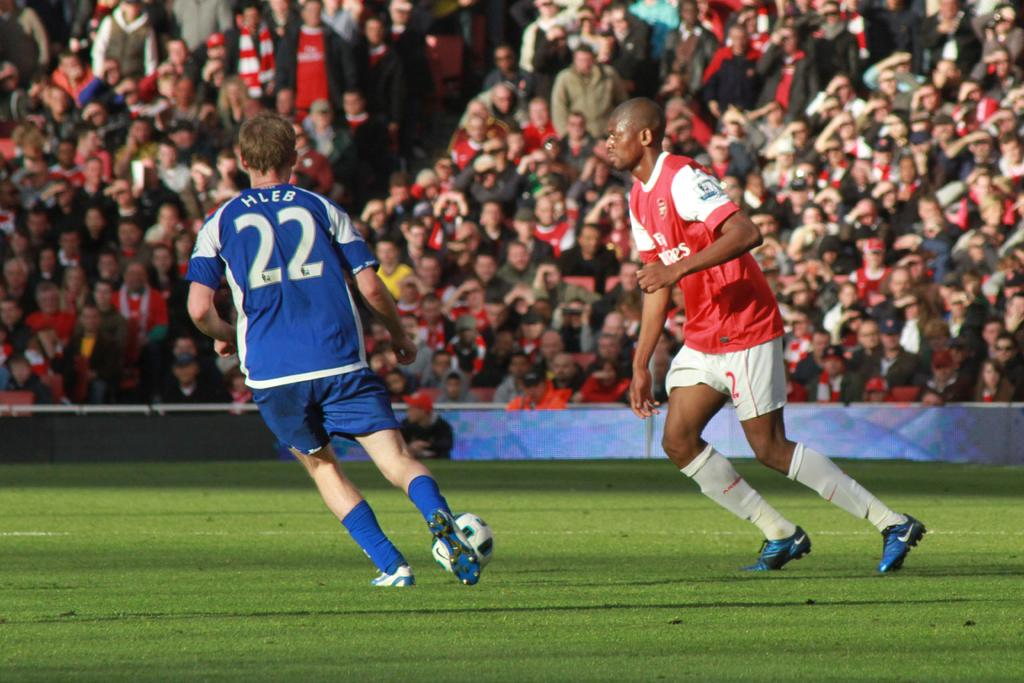Provide a one-sentence caption for the provided image. Two players are on a field and one wears a jersey with the number 22 on it. 